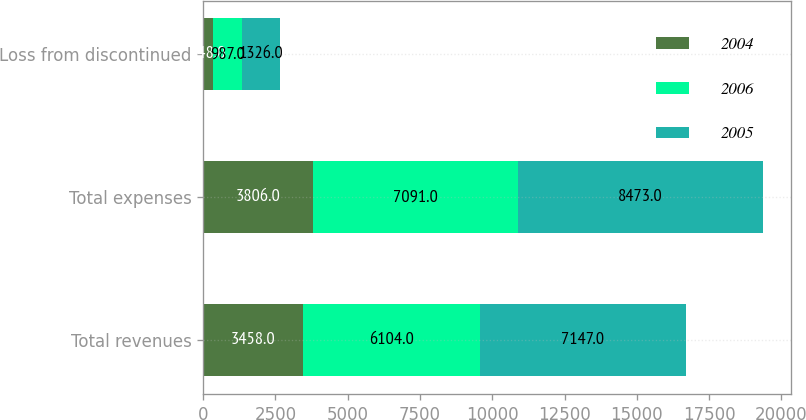Convert chart to OTSL. <chart><loc_0><loc_0><loc_500><loc_500><stacked_bar_chart><ecel><fcel>Total revenues<fcel>Total expenses<fcel>Loss from discontinued<nl><fcel>2004<fcel>3458<fcel>3806<fcel>348<nl><fcel>2006<fcel>6104<fcel>7091<fcel>987<nl><fcel>2005<fcel>7147<fcel>8473<fcel>1326<nl></chart> 